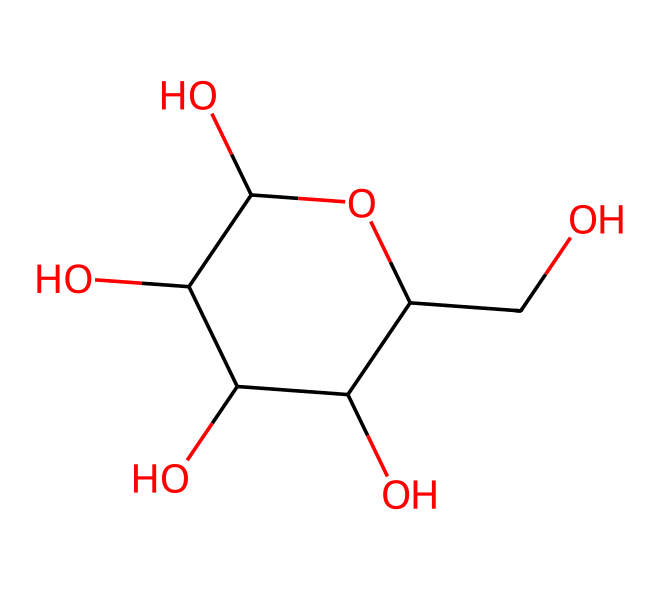What is the chemical name of this structure? The SMILES provided corresponds to a carbohydrate, specifically the structure can be identified as glucose. The arrangement of carbon, hydrogen, and oxygen atoms in the cyclic form identifies it as glucose.
Answer: glucose How many carbon atoms are in this molecule? By analyzing the given SMILES structure, we observe that there are six carbon atoms (C) present in the molecule. Each carbon is represented explicitly in the structure, confirming the count.
Answer: six What is the molecular formula of this glucose structure? The structure features six carbon atoms, twelve hydrogen atoms, and six oxygen atoms, derived from its cyclic form. Therefore, the molecular formula can be derived as C6H12O6.
Answer: C6H12O6 What type of carbohydrate is glucose? Glucose is a simple sugar, or monosaccharide, as it consists of a single sugar unit. This classification is based on the chemical structure that does not break down into simpler carbohydrates.
Answer: monosaccharide Why is glucose significant in diabetic nephropathy? Glucose plays a critical role in diabetic nephropathy due to its contribution to hyperglycemia, leading to kidney damage over time. Elevated glucose levels result in increased glycation of proteins and can cause subsequent damage to kidney filtration units.
Answer: kidney damage 